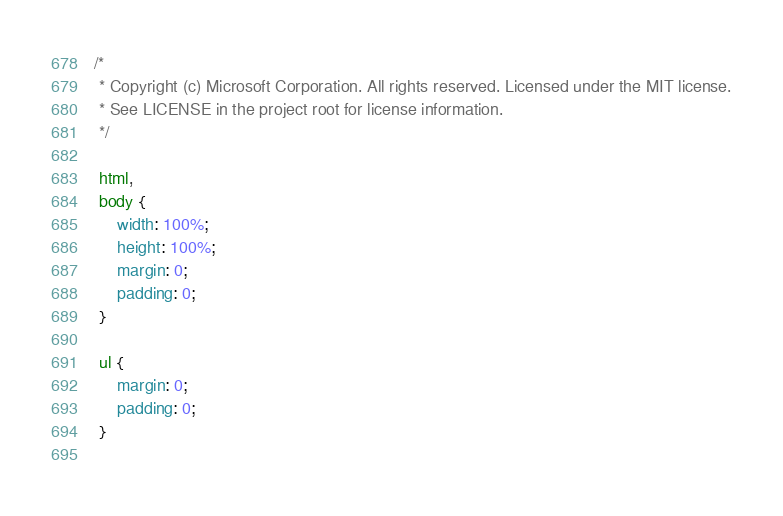<code> <loc_0><loc_0><loc_500><loc_500><_CSS_>/* 
 * Copyright (c) Microsoft Corporation. All rights reserved. Licensed under the MIT license.
 * See LICENSE in the project root for license information.
 */

 html,
 body {
     width: 100%;
     height: 100%;
     margin: 0;
     padding: 0;
 }
 
 ul {
     margin: 0;
     padding: 0;
 }
 </code> 